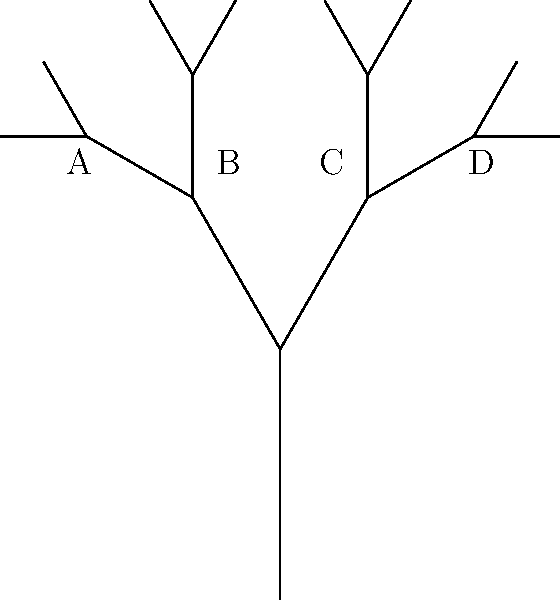In the phylogenetic tree shown above, which two species are most closely related based on the topology? To determine which two species are most closely related in a phylogenetic tree, we need to follow these steps:

1. Identify the terminal nodes (tips) of the tree, which represent the extant species. In this case, they are labeled A, B, C, and D.

2. Trace back from each terminal node to find the most recent common ancestor (MRCA) for each pair of species.

3. The pair of species with the MRCA closest to the terminal nodes (i.e., with the fewest number of branching points between them) are the most closely related.

Analyzing the tree:
- A and B share a common ancestor at the second-to-last branching point.
- C and D also share a common ancestor at the second-to-last branching point.
- The common ancestor of A and C (or B and D) is at the first branching point, which is further back in time.

Therefore, A and B are most closely related to each other, as are C and D. However, A and B have a more recent common ancestor than any other pair of species in this tree.
Answer: A and B 